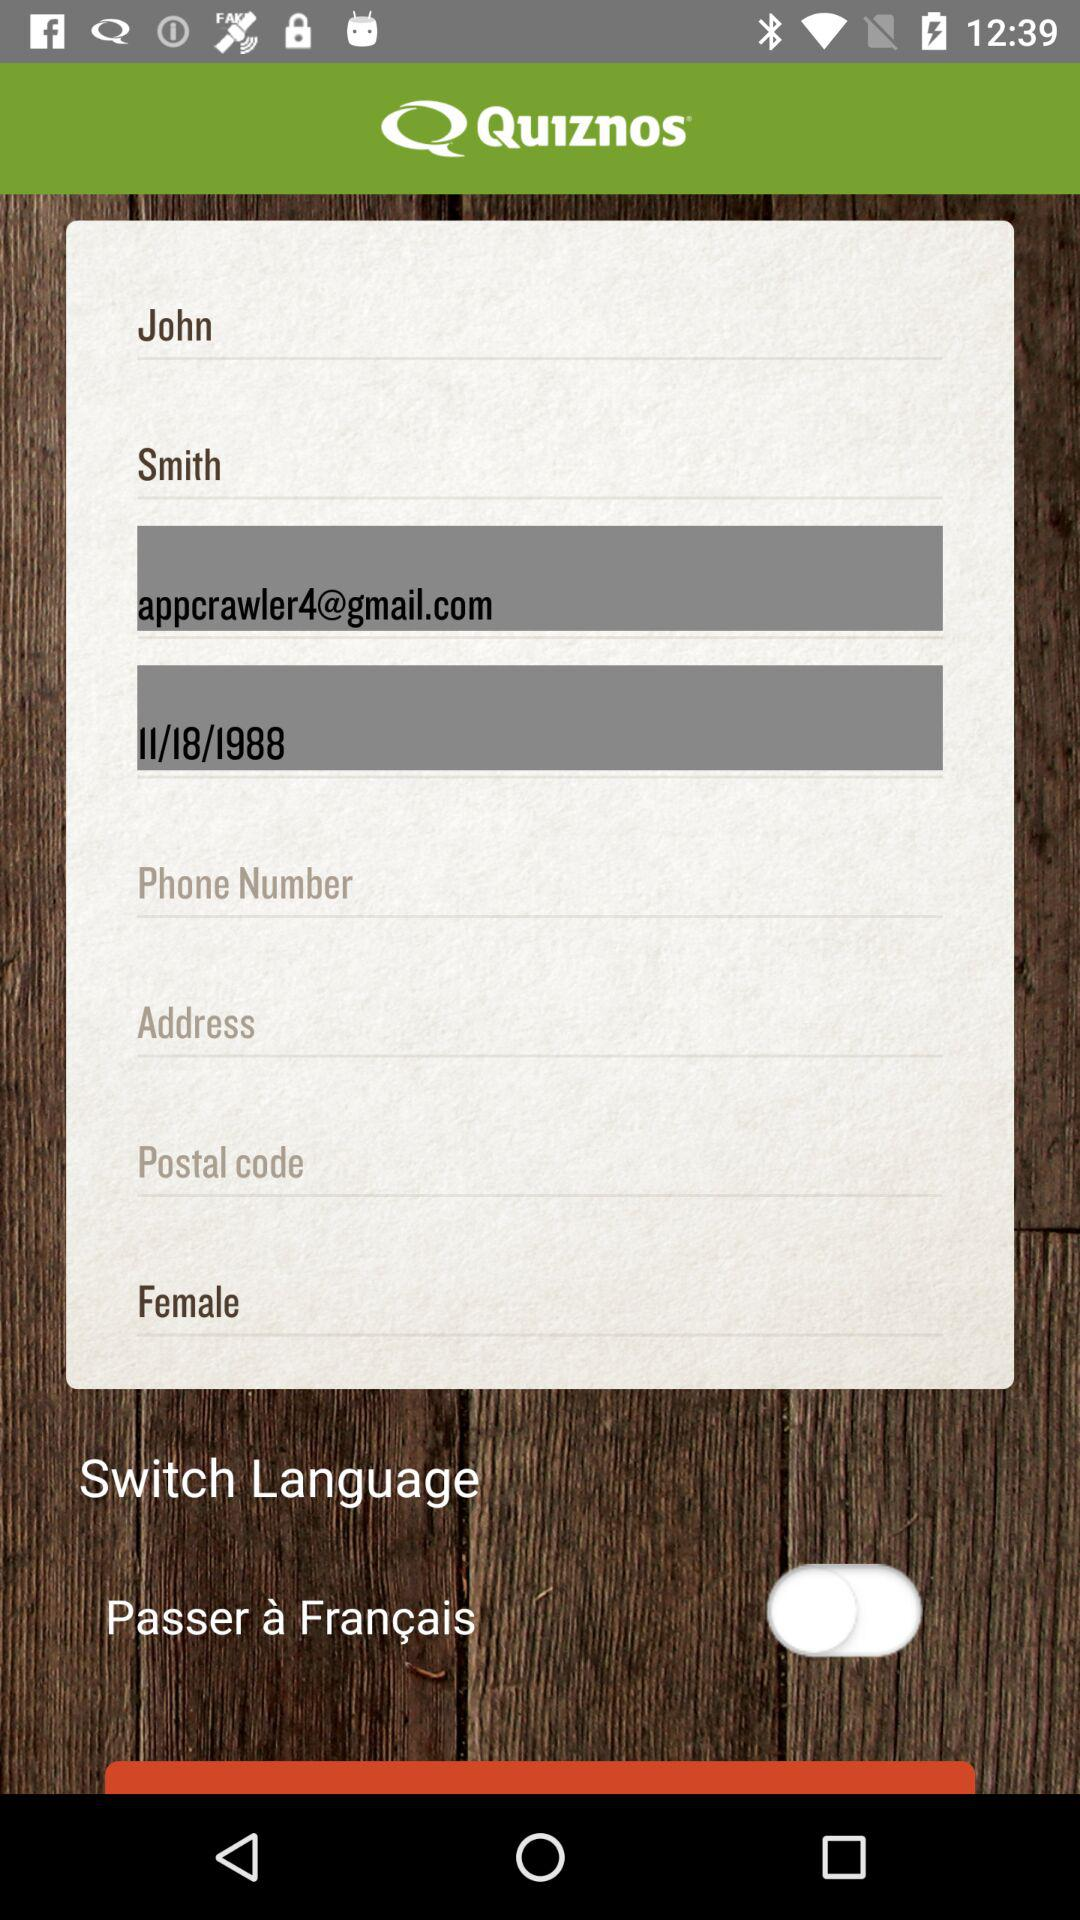What is the email address? The email address is appcrawler4@gmail.com. 